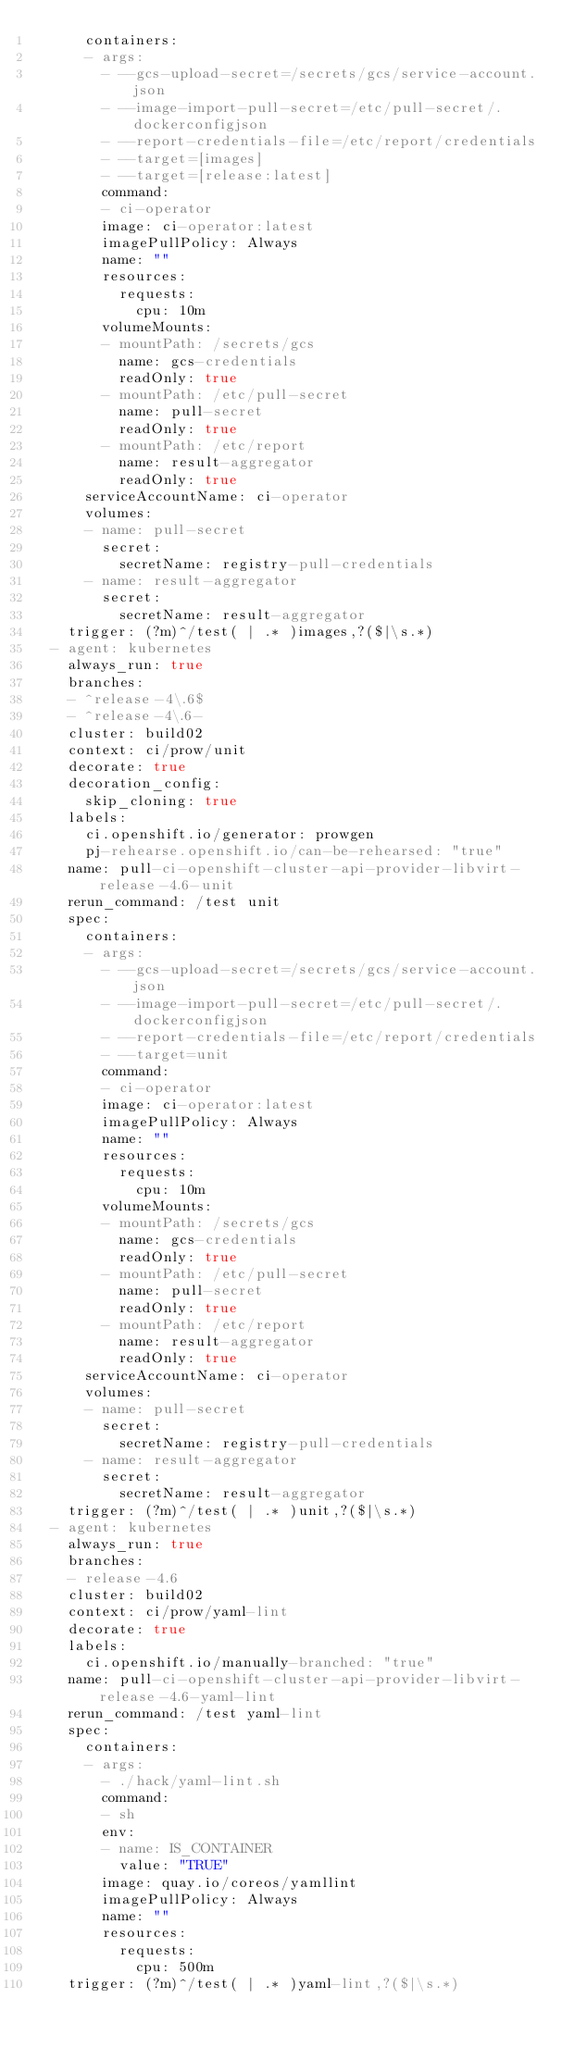<code> <loc_0><loc_0><loc_500><loc_500><_YAML_>      containers:
      - args:
        - --gcs-upload-secret=/secrets/gcs/service-account.json
        - --image-import-pull-secret=/etc/pull-secret/.dockerconfigjson
        - --report-credentials-file=/etc/report/credentials
        - --target=[images]
        - --target=[release:latest]
        command:
        - ci-operator
        image: ci-operator:latest
        imagePullPolicy: Always
        name: ""
        resources:
          requests:
            cpu: 10m
        volumeMounts:
        - mountPath: /secrets/gcs
          name: gcs-credentials
          readOnly: true
        - mountPath: /etc/pull-secret
          name: pull-secret
          readOnly: true
        - mountPath: /etc/report
          name: result-aggregator
          readOnly: true
      serviceAccountName: ci-operator
      volumes:
      - name: pull-secret
        secret:
          secretName: registry-pull-credentials
      - name: result-aggregator
        secret:
          secretName: result-aggregator
    trigger: (?m)^/test( | .* )images,?($|\s.*)
  - agent: kubernetes
    always_run: true
    branches:
    - ^release-4\.6$
    - ^release-4\.6-
    cluster: build02
    context: ci/prow/unit
    decorate: true
    decoration_config:
      skip_cloning: true
    labels:
      ci.openshift.io/generator: prowgen
      pj-rehearse.openshift.io/can-be-rehearsed: "true"
    name: pull-ci-openshift-cluster-api-provider-libvirt-release-4.6-unit
    rerun_command: /test unit
    spec:
      containers:
      - args:
        - --gcs-upload-secret=/secrets/gcs/service-account.json
        - --image-import-pull-secret=/etc/pull-secret/.dockerconfigjson
        - --report-credentials-file=/etc/report/credentials
        - --target=unit
        command:
        - ci-operator
        image: ci-operator:latest
        imagePullPolicy: Always
        name: ""
        resources:
          requests:
            cpu: 10m
        volumeMounts:
        - mountPath: /secrets/gcs
          name: gcs-credentials
          readOnly: true
        - mountPath: /etc/pull-secret
          name: pull-secret
          readOnly: true
        - mountPath: /etc/report
          name: result-aggregator
          readOnly: true
      serviceAccountName: ci-operator
      volumes:
      - name: pull-secret
        secret:
          secretName: registry-pull-credentials
      - name: result-aggregator
        secret:
          secretName: result-aggregator
    trigger: (?m)^/test( | .* )unit,?($|\s.*)
  - agent: kubernetes
    always_run: true
    branches:
    - release-4.6
    cluster: build02
    context: ci/prow/yaml-lint
    decorate: true
    labels:
      ci.openshift.io/manually-branched: "true"
    name: pull-ci-openshift-cluster-api-provider-libvirt-release-4.6-yaml-lint
    rerun_command: /test yaml-lint
    spec:
      containers:
      - args:
        - ./hack/yaml-lint.sh
        command:
        - sh
        env:
        - name: IS_CONTAINER
          value: "TRUE"
        image: quay.io/coreos/yamllint
        imagePullPolicy: Always
        name: ""
        resources:
          requests:
            cpu: 500m
    trigger: (?m)^/test( | .* )yaml-lint,?($|\s.*)
</code> 